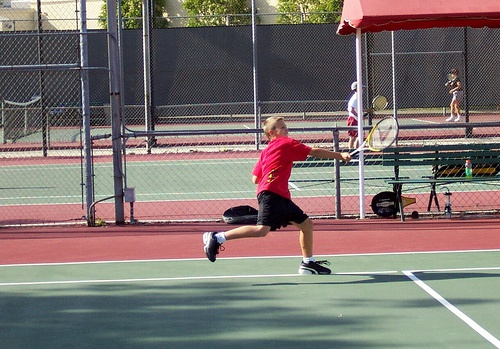Describe the objects in this image and their specific colors. I can see people in gray, black, brown, and maroon tones, bench in gray, black, darkgray, and darkblue tones, tennis racket in gray, lightgray, darkgray, and beige tones, people in gray, white, purple, and maroon tones, and people in gray, brown, maroon, and black tones in this image. 